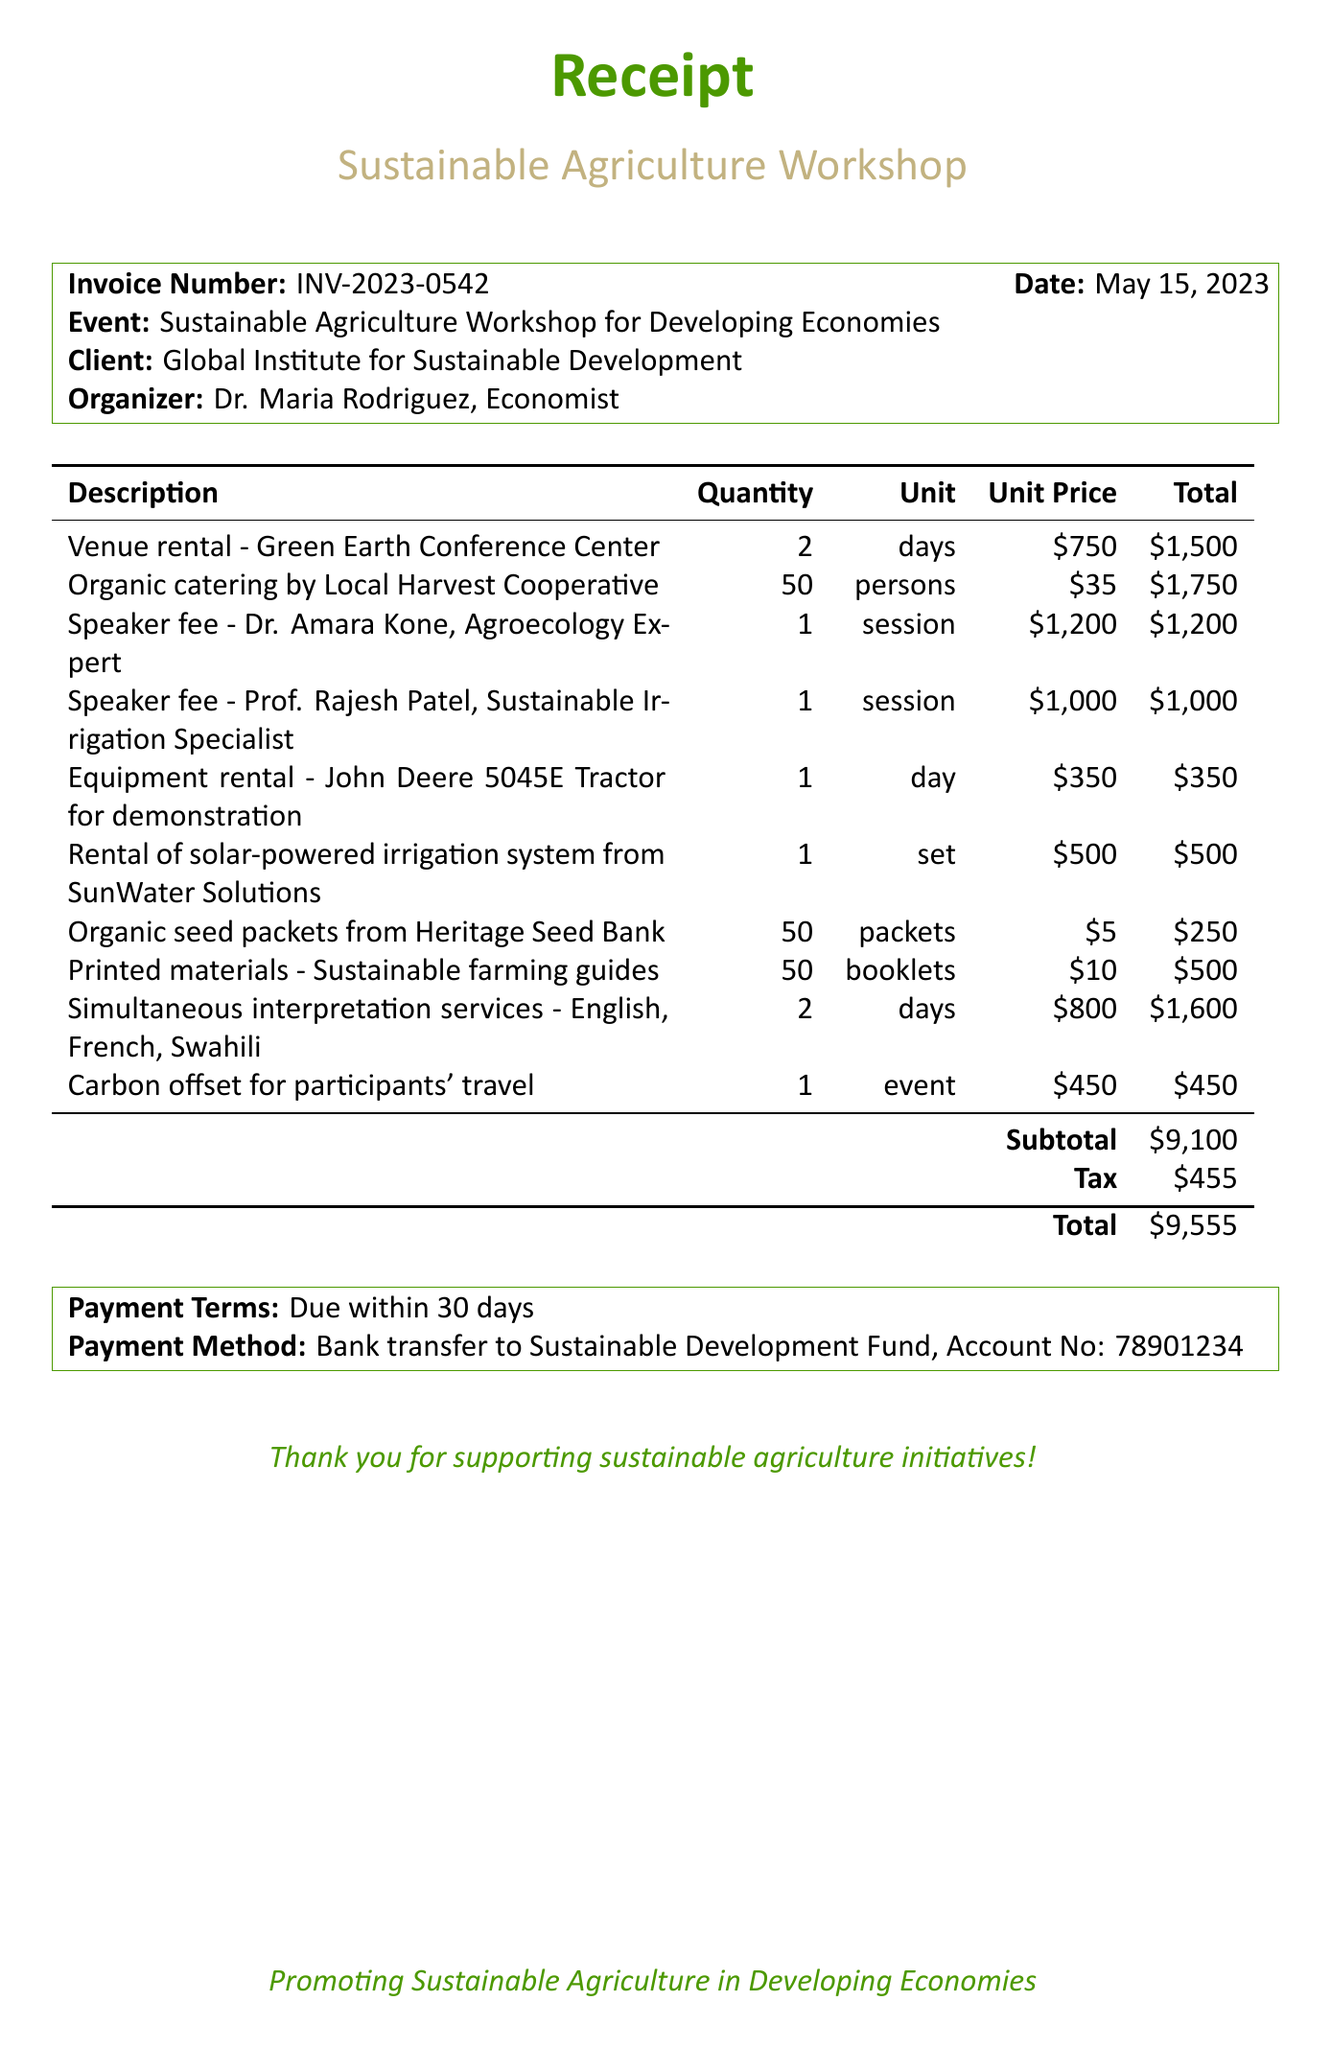What is the invoice number? The invoice number is explicitly stated in the document for reference.
Answer: INV-2023-0542 What is the date of the workshop? The date is provided clearly in the header of the invoice.
Answer: May 15, 2023 Who is the client for this workshop? The client’s name is listed prominently in the document.
Answer: Global Institute for Sustainable Development What is the total amount due? The total amount is calculated by adding the subtotal and tax, which is prominently shown.
Answer: $9,555 How many days was the venue rented for? The number of days the venue was rented is specified in the items list.
Answer: 2 What is the unit price for organic catering per person? The unit price for catering is provided alongside the quantity in the invoice.
Answer: $35 What is the speaker fee for Dr. Amara Kone? The speaker fee information includes the name and the amount charged for the session.
Answer: $1,200 What type of payment method is accepted? The payment method is explicitly mentioned in a dedicated section of the document.
Answer: Bank transfer How many organic seed packets were purchased? The quantity of organic seed packets is detailed in the items list of the invoice.
Answer: 50 What services are included for simultaneous interpretation? This refers to the type of languages offered for interpretation as listed in the invoice.
Answer: English, French, Swahili 